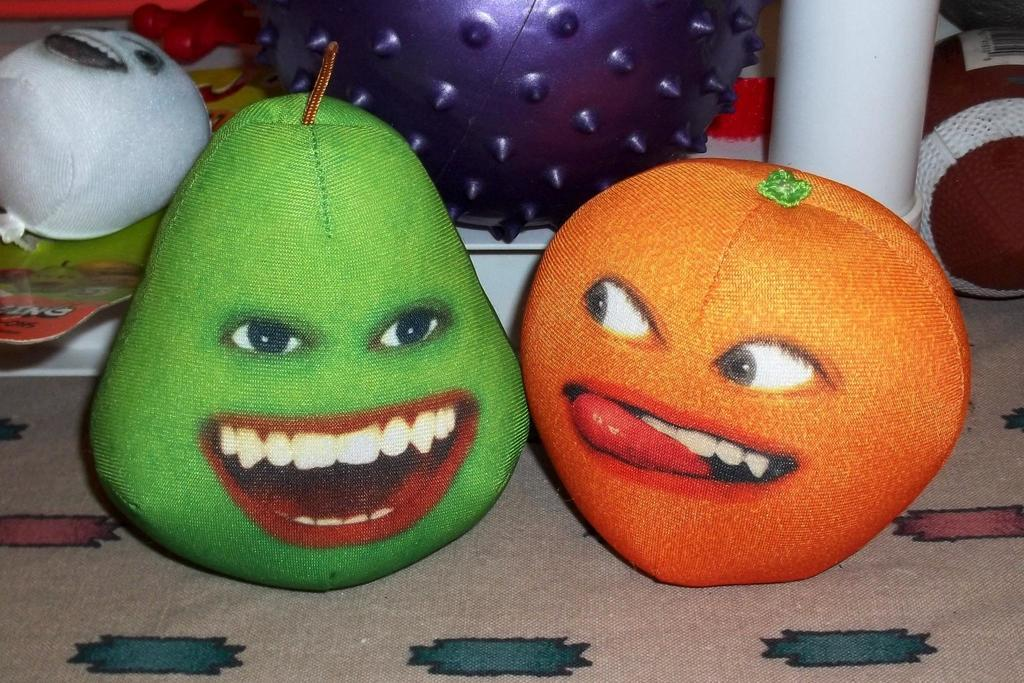What objects can be seen in the image? There are toys in the image. Where are the toys placed? The toys are on a cloth. What type of dress is the cat wearing in the image? There are no cats or dresses present in the image; it only features toys on a cloth. 